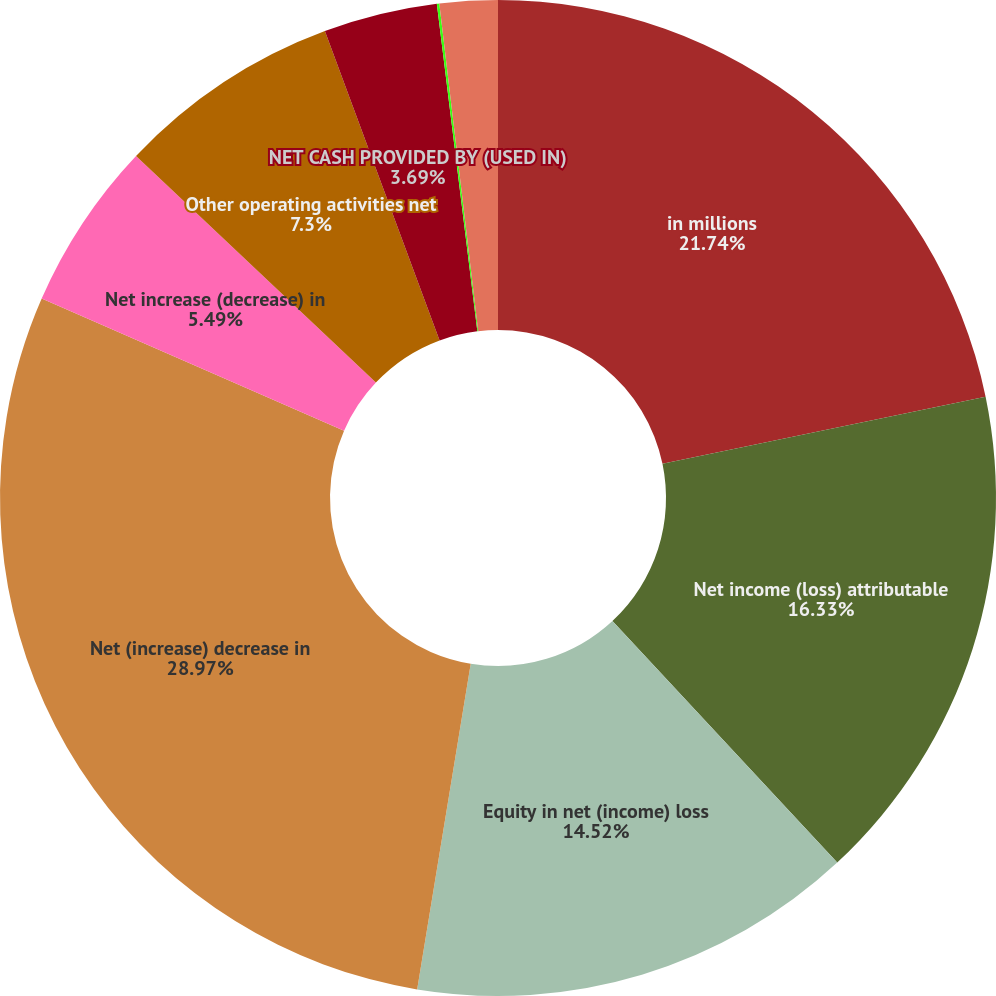Convert chart. <chart><loc_0><loc_0><loc_500><loc_500><pie_chart><fcel>in millions<fcel>Net income (loss) attributable<fcel>Equity in net (income) loss<fcel>Net (increase) decrease in<fcel>Net increase (decrease) in<fcel>Other operating activities net<fcel>NET CASH PROVIDED BY (USED IN)<fcel>Purchases of securities<fcel>Proceeds from sales<nl><fcel>21.74%<fcel>16.33%<fcel>14.52%<fcel>28.96%<fcel>5.49%<fcel>7.3%<fcel>3.69%<fcel>0.08%<fcel>1.88%<nl></chart> 